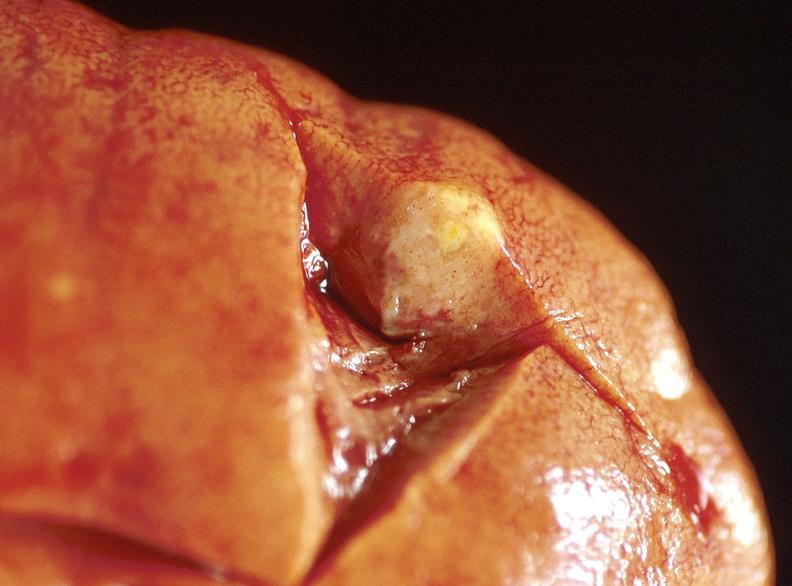does this image show kidney, metastatic lung carcinoma?
Answer the question using a single word or phrase. Yes 